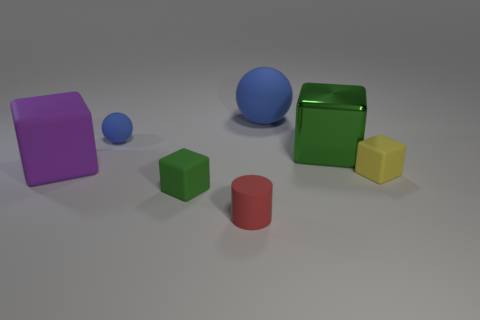Subtract all yellow balls. How many green blocks are left? 2 Subtract all rubber blocks. How many blocks are left? 1 Subtract all purple cubes. How many cubes are left? 3 Subtract 2 blocks. How many blocks are left? 2 Add 2 tiny spheres. How many objects exist? 9 Subtract all red blocks. Subtract all blue balls. How many blocks are left? 4 Subtract all cylinders. How many objects are left? 6 Add 4 red things. How many red things exist? 5 Subtract 0 red cubes. How many objects are left? 7 Subtract all cubes. Subtract all tiny red shiny cylinders. How many objects are left? 3 